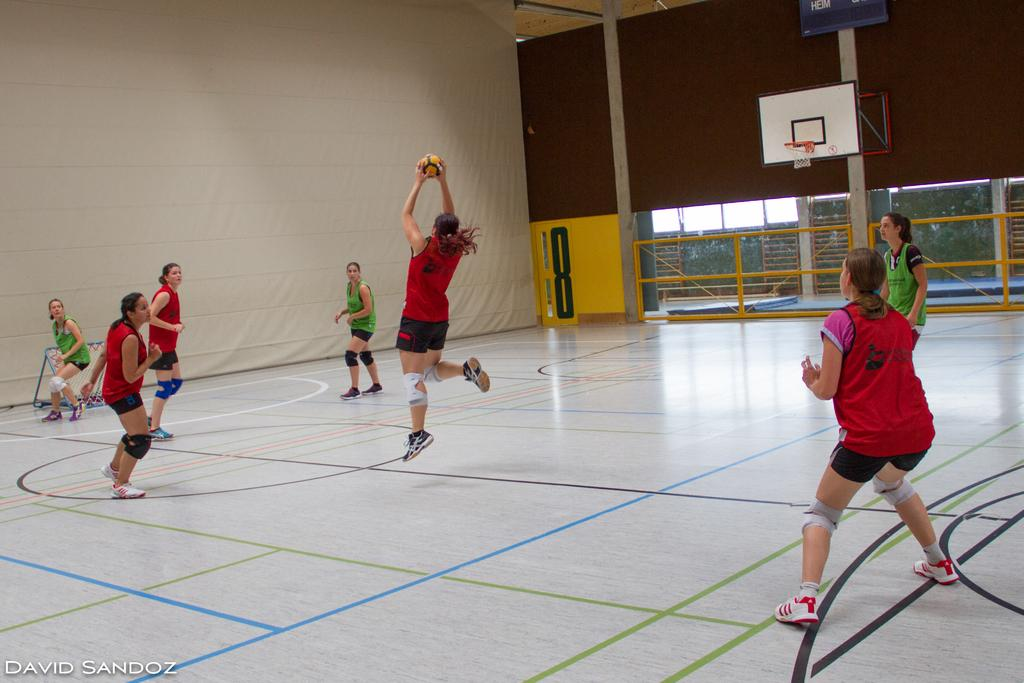What are the women in the image doing? The women in the image are running. What is one of the women holding? One of the women is holding a ball. What type of structure can be seen in the image? There are iron grills in the image. What type of natural environment is visible in the image? There are trees visible in the image. What is visible in the background of the image? The sky is visible in the image. What is the wealth status of the women in the image? There is no information about the wealth status of the women in the image. Is there a bed present in the image? No, there is no bed present in the image. 